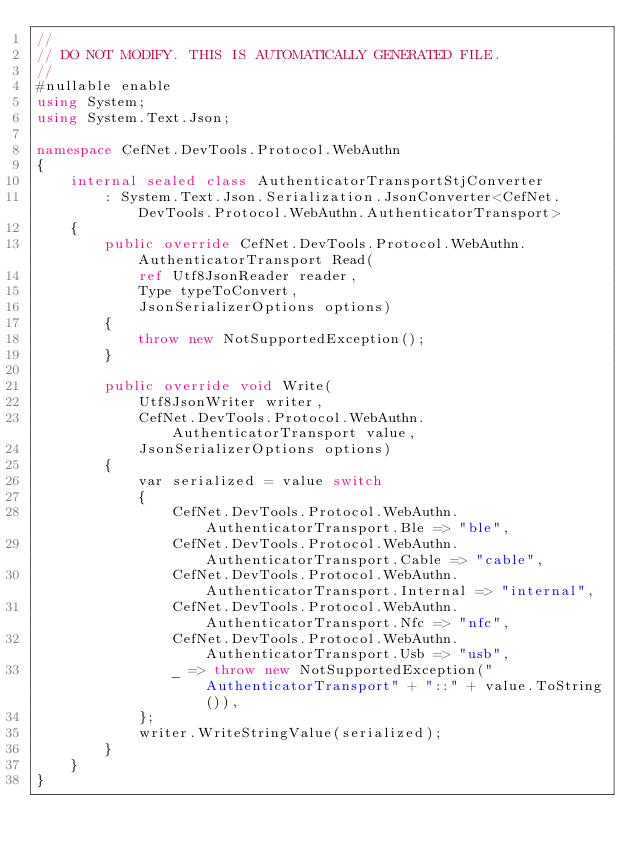Convert code to text. <code><loc_0><loc_0><loc_500><loc_500><_C#_>//
// DO NOT MODIFY. THIS IS AUTOMATICALLY GENERATED FILE.
//
#nullable enable
using System;
using System.Text.Json;

namespace CefNet.DevTools.Protocol.WebAuthn
{
    internal sealed class AuthenticatorTransportStjConverter
        : System.Text.Json.Serialization.JsonConverter<CefNet.DevTools.Protocol.WebAuthn.AuthenticatorTransport>
    {
        public override CefNet.DevTools.Protocol.WebAuthn.AuthenticatorTransport Read(
            ref Utf8JsonReader reader, 
            Type typeToConvert, 
            JsonSerializerOptions options)
        {
            throw new NotSupportedException();
        }

        public override void Write(
            Utf8JsonWriter writer, 
            CefNet.DevTools.Protocol.WebAuthn.AuthenticatorTransport value, 
            JsonSerializerOptions options)
        {
            var serialized = value switch
            {
                CefNet.DevTools.Protocol.WebAuthn.AuthenticatorTransport.Ble => "ble",
                CefNet.DevTools.Protocol.WebAuthn.AuthenticatorTransport.Cable => "cable",
                CefNet.DevTools.Protocol.WebAuthn.AuthenticatorTransport.Internal => "internal",
                CefNet.DevTools.Protocol.WebAuthn.AuthenticatorTransport.Nfc => "nfc",
                CefNet.DevTools.Protocol.WebAuthn.AuthenticatorTransport.Usb => "usb",
                _ => throw new NotSupportedException("AuthenticatorTransport" + "::" + value.ToString()),
            };
            writer.WriteStringValue(serialized);
        }
    }
}
</code> 